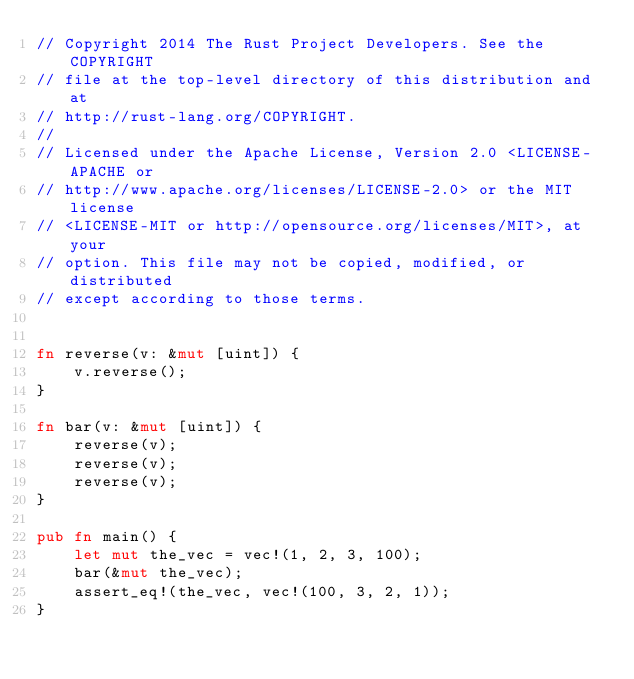Convert code to text. <code><loc_0><loc_0><loc_500><loc_500><_Rust_>// Copyright 2014 The Rust Project Developers. See the COPYRIGHT
// file at the top-level directory of this distribution and at
// http://rust-lang.org/COPYRIGHT.
//
// Licensed under the Apache License, Version 2.0 <LICENSE-APACHE or
// http://www.apache.org/licenses/LICENSE-2.0> or the MIT license
// <LICENSE-MIT or http://opensource.org/licenses/MIT>, at your
// option. This file may not be copied, modified, or distributed
// except according to those terms.


fn reverse(v: &mut [uint]) {
    v.reverse();
}

fn bar(v: &mut [uint]) {
    reverse(v);
    reverse(v);
    reverse(v);
}

pub fn main() {
    let mut the_vec = vec!(1, 2, 3, 100);
    bar(&mut the_vec);
    assert_eq!(the_vec, vec!(100, 3, 2, 1));
}
</code> 